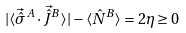<formula> <loc_0><loc_0><loc_500><loc_500>| \langle \vec { \hat { \sigma } } ^ { A } \cdot \vec { \hat { J } } ^ { B } \rangle | - \langle \hat { N } ^ { B } \rangle = 2 \eta \geq 0</formula> 